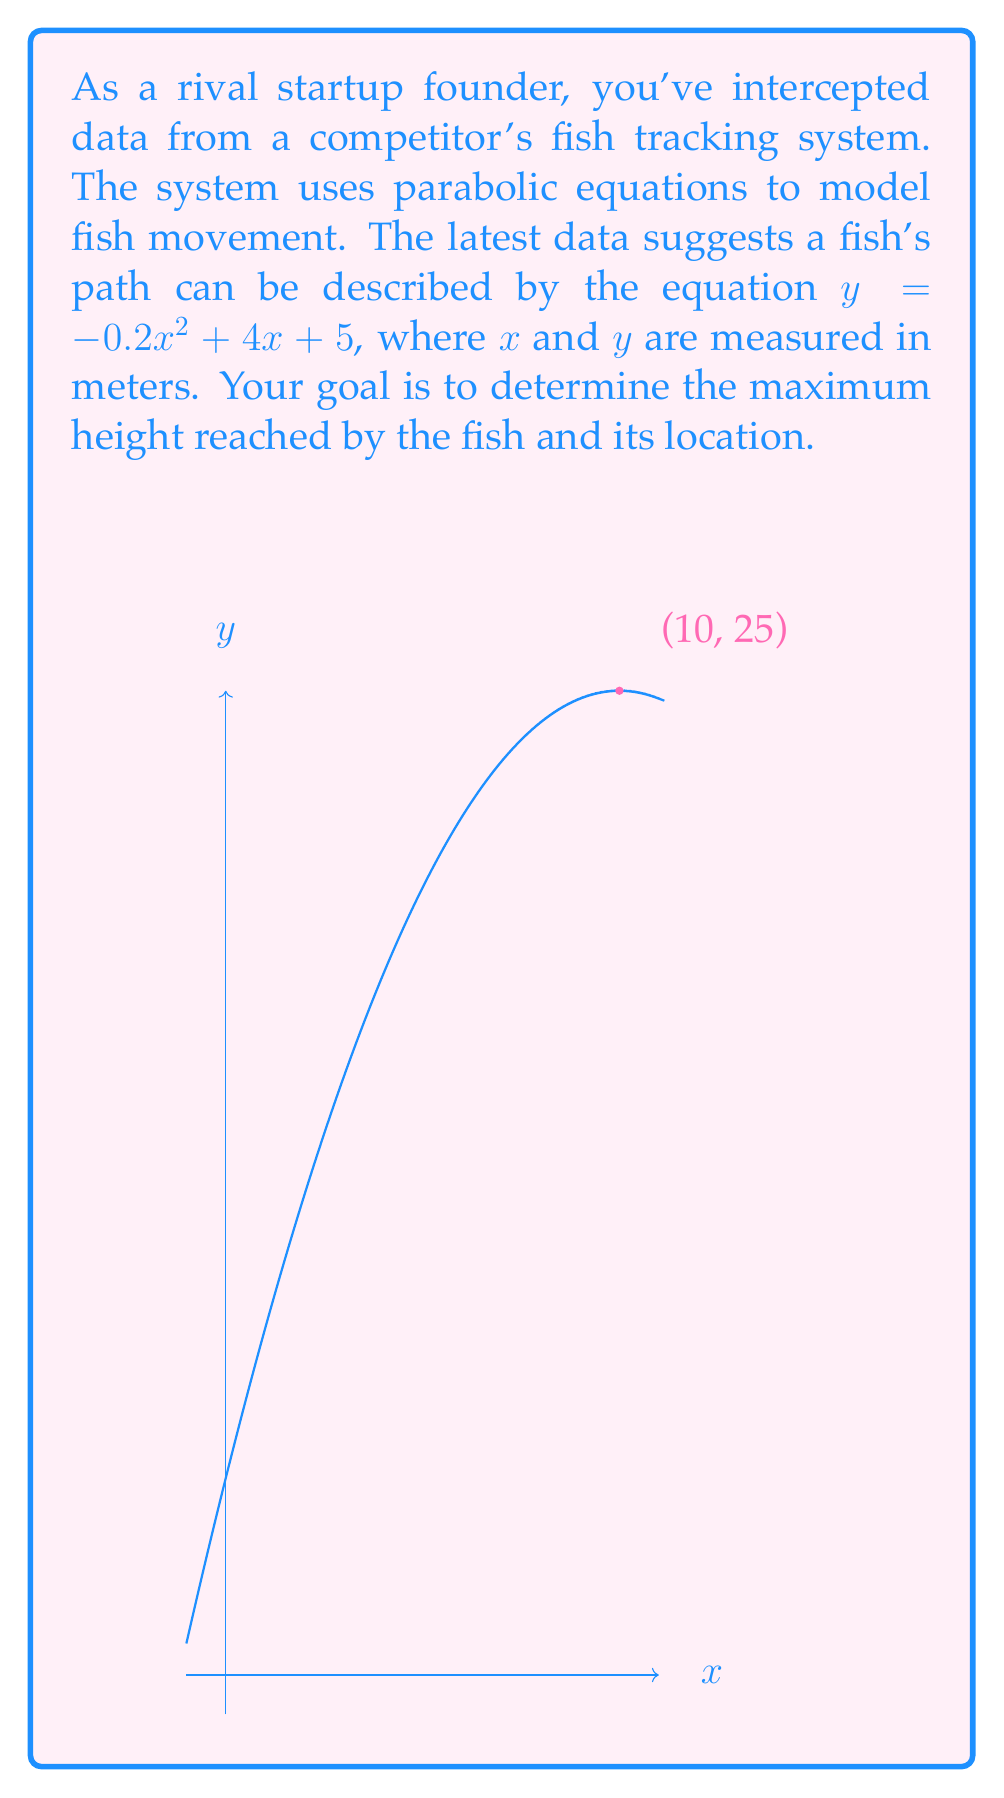Solve this math problem. To find the maximum height of the parabola and its location, we need to follow these steps:

1) The general form of a parabola is $y = ax^2 + bx + c$, where $a$, $b$, and $c$ are constants and $a \neq 0$. In this case, we have:

   $y = -0.2x^2 + 4x + 5$

   So, $a = -0.2$, $b = 4$, and $c = 5$

2) For a parabola, the x-coordinate of the vertex (which represents the maximum or minimum point) is given by the formula:

   $x = -\frac{b}{2a}$

3) Substituting our values:

   $x = -\frac{4}{2(-0.2)} = -\frac{4}{-0.4} = 10$

4) To find the y-coordinate of the vertex (the maximum height), we substitute this x-value back into the original equation:

   $y = -0.2(10)^2 + 4(10) + 5$
   $= -0.2(100) + 40 + 5$
   $= -20 + 40 + 5$
   $= 25$

5) Therefore, the vertex of the parabola is at the point (10, 25).

This means the fish reaches its maximum height of 25 meters when it's 10 meters along the x-axis.
Answer: Maximum height: 25 meters; Location: (10, 25) 